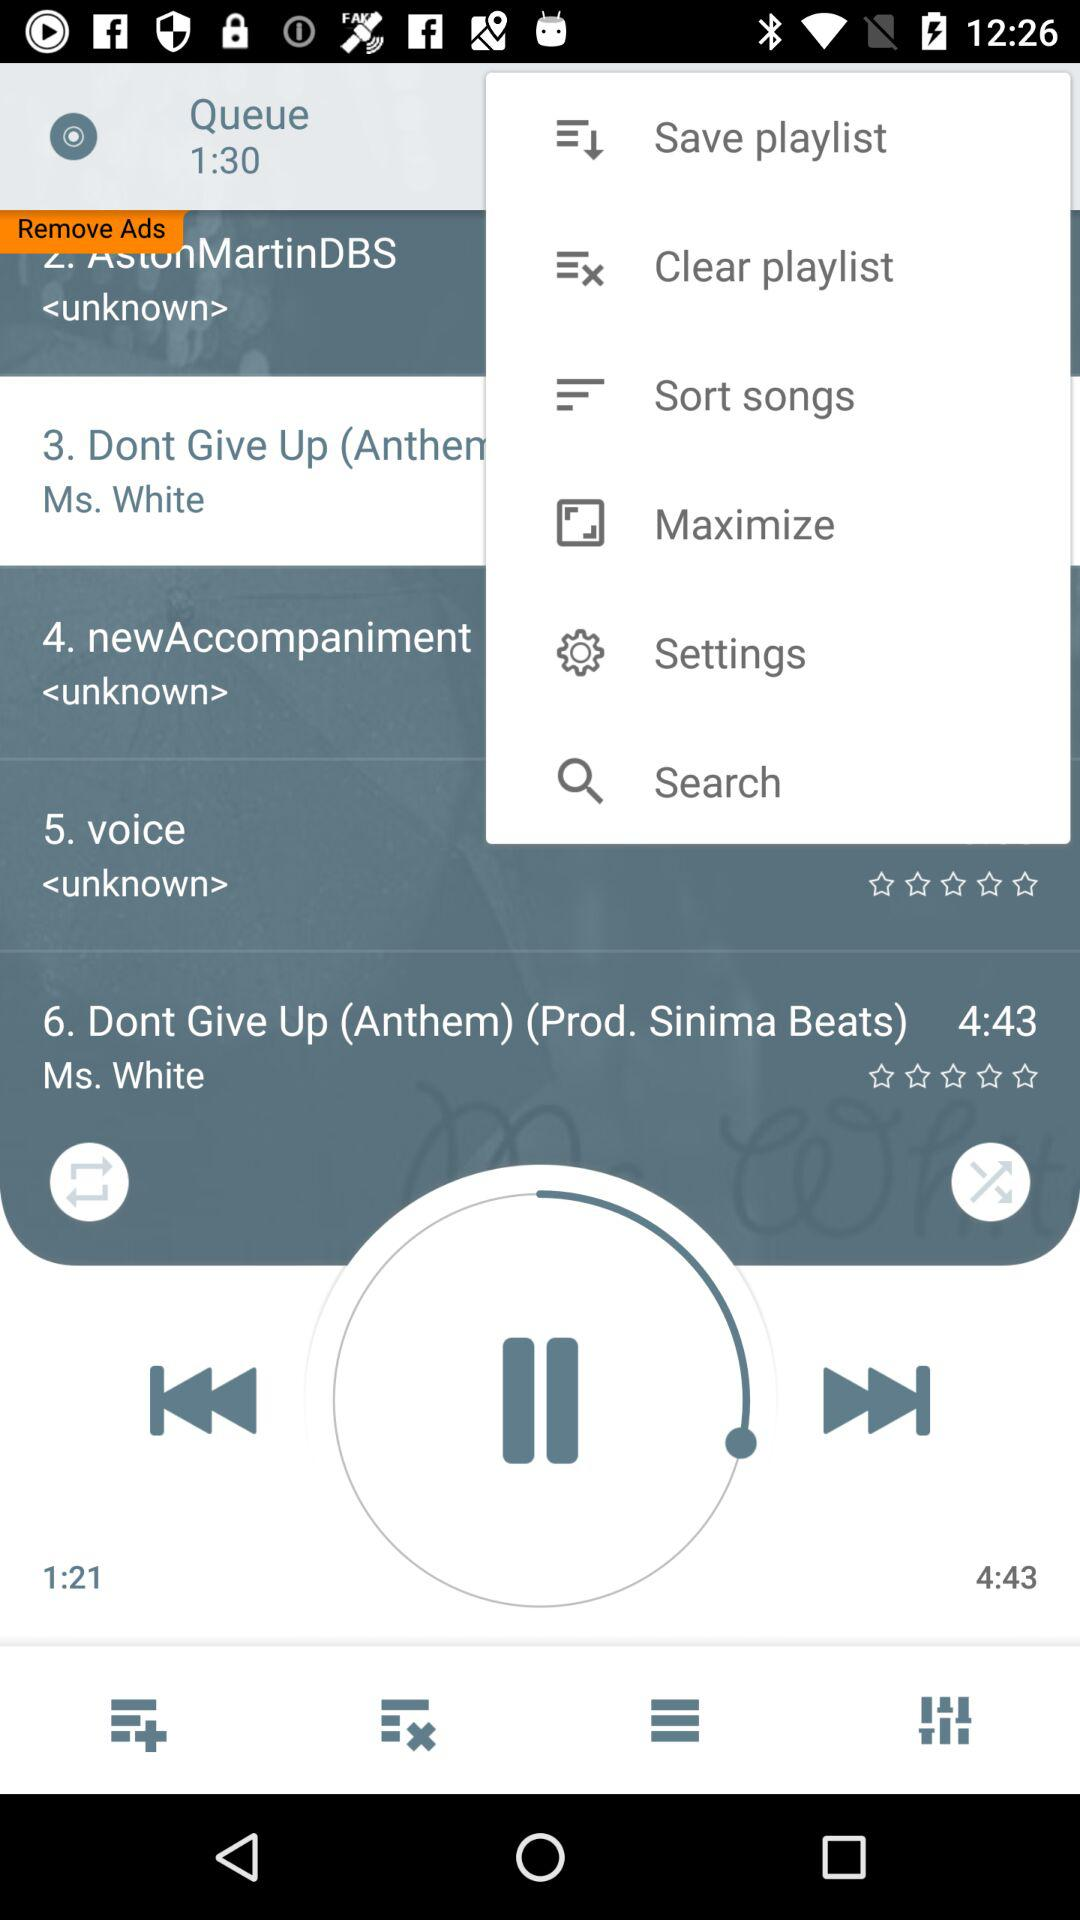What duration is mentioned in "Queue"? The duration mentioned in "Queue" is 1 minute 30 seconds. 